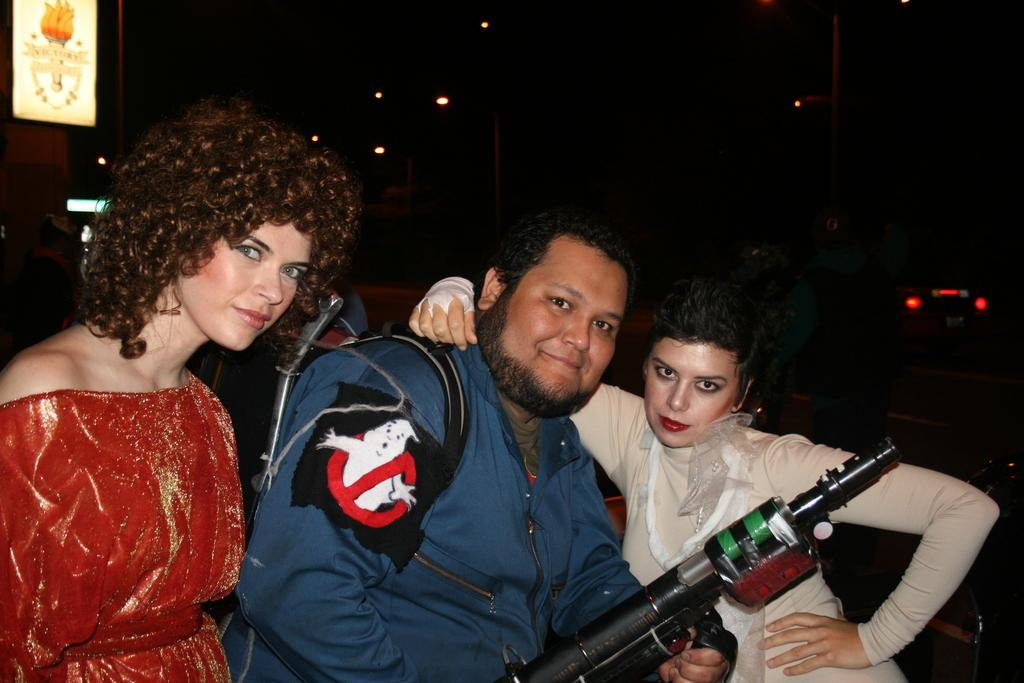How many people are in the image? There are three people standing in the image. What is the man holding in the image? The man is holding a gun in the image. What can be seen in the image besides the people? There are lights visible in the image. How would you describe the overall lighting in the image? The background of the image is dark. What type of stamp can be seen on the man's forehead in the image? There is no stamp present on the man's forehead in the image. 